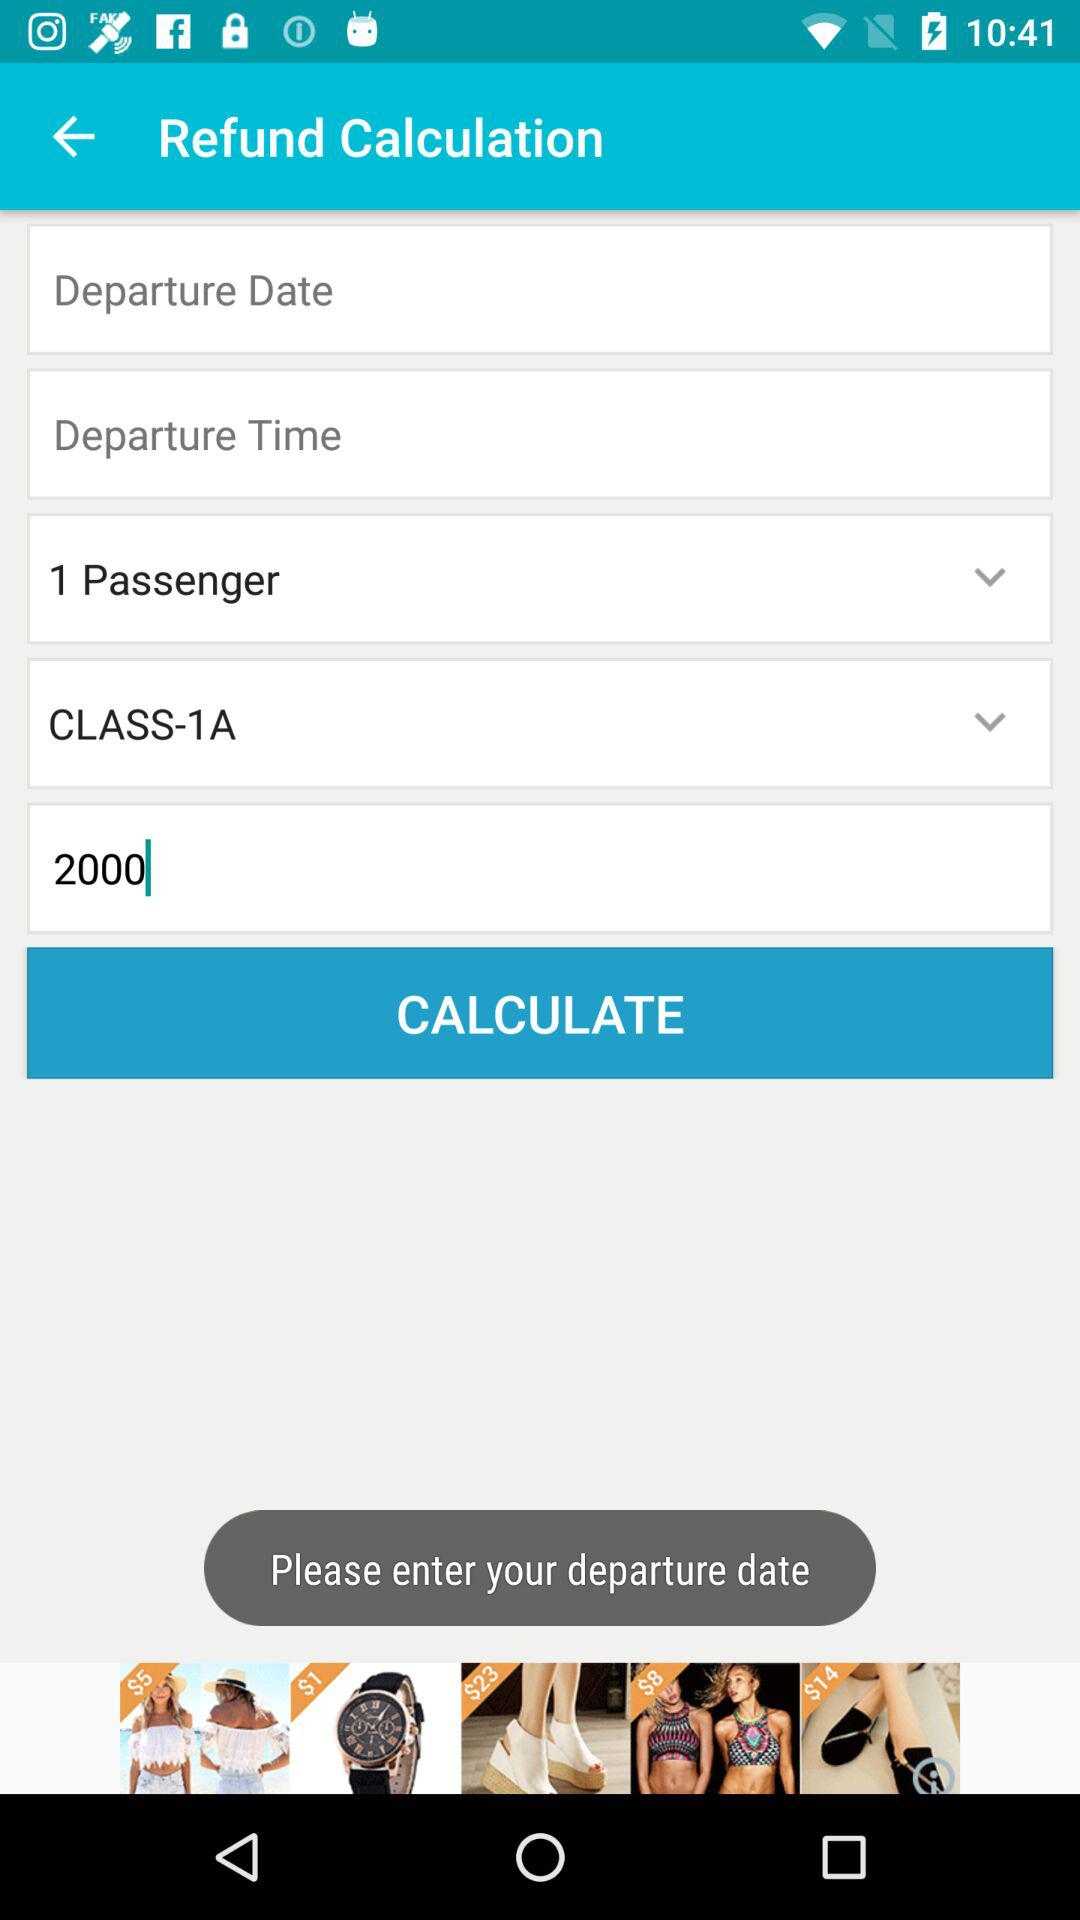What is the selected class? The selected class is "CLASS-1A". 